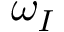Convert formula to latex. <formula><loc_0><loc_0><loc_500><loc_500>\omega _ { I }</formula> 